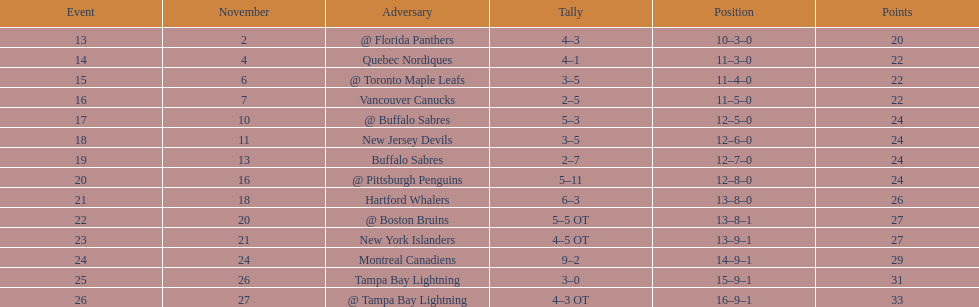Were the new jersey devils in last place according to the chart? No. 